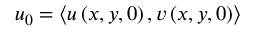<formula> <loc_0><loc_0><loc_500><loc_500>u _ { 0 } = \left < u \left ( x , y , 0 \right ) , v \left ( x , y , 0 \right ) \right ></formula> 